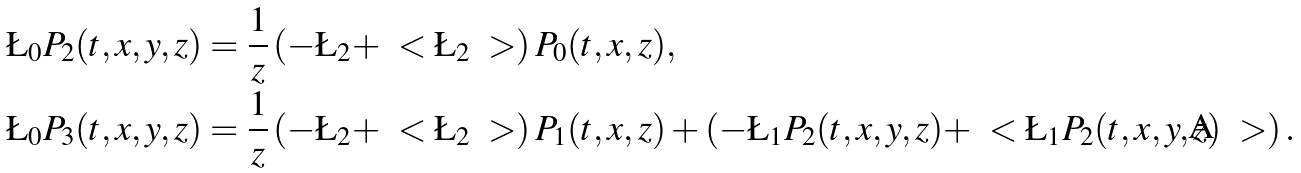<formula> <loc_0><loc_0><loc_500><loc_500>\L _ { 0 } P _ { 2 } ( t , x , y , z ) & = \frac { 1 } { z } \left ( - \L _ { 2 } + \ < \L _ { 2 } \ > \right ) P _ { 0 } ( t , x , z ) , \\ \L _ { 0 } P _ { 3 } ( t , x , y , z ) & = \frac { 1 } { z } \left ( - \L _ { 2 } + \ < \L _ { 2 } \ > \right ) P _ { 1 } ( t , x , z ) + \left ( - \L _ { 1 } P _ { 2 } ( t , x , y , z ) + \ < \L _ { 1 } P _ { 2 } ( t , x , y , z ) \ > \right ) .</formula> 